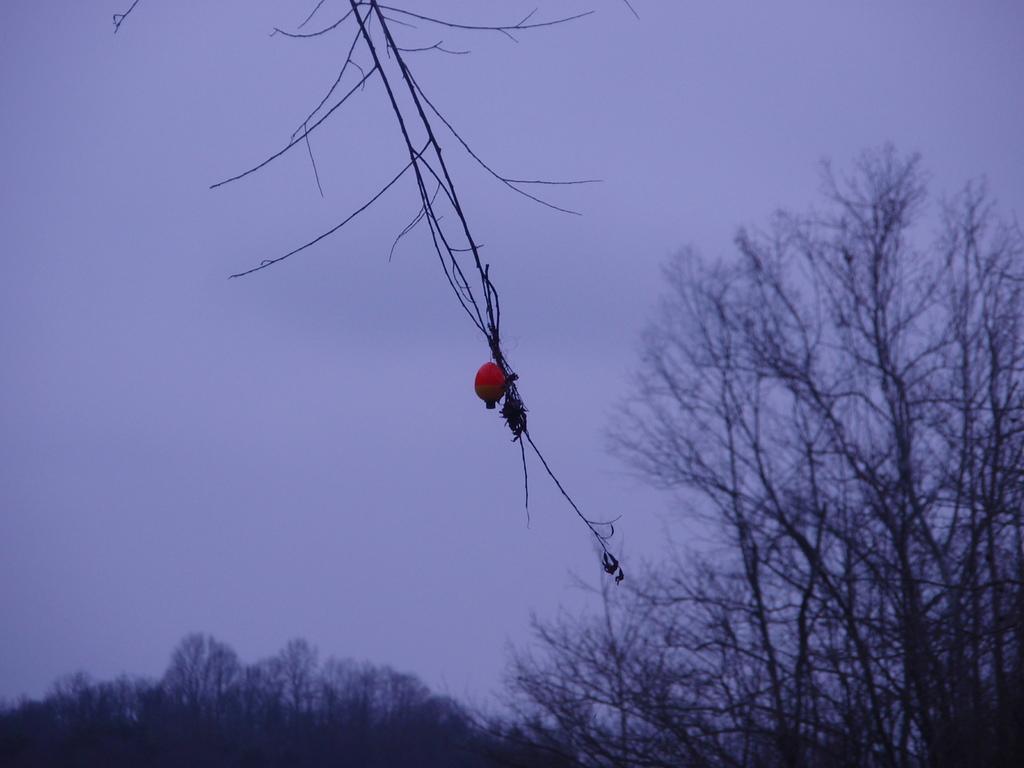In one or two sentences, can you explain what this image depicts? In the center of the image there is a fruit on tree branch. In the background of the image there are trees and sky. 